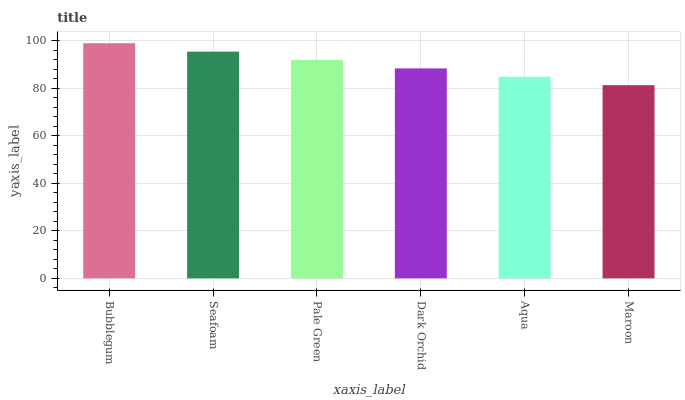Is Maroon the minimum?
Answer yes or no. Yes. Is Bubblegum the maximum?
Answer yes or no. Yes. Is Seafoam the minimum?
Answer yes or no. No. Is Seafoam the maximum?
Answer yes or no. No. Is Bubblegum greater than Seafoam?
Answer yes or no. Yes. Is Seafoam less than Bubblegum?
Answer yes or no. Yes. Is Seafoam greater than Bubblegum?
Answer yes or no. No. Is Bubblegum less than Seafoam?
Answer yes or no. No. Is Pale Green the high median?
Answer yes or no. Yes. Is Dark Orchid the low median?
Answer yes or no. Yes. Is Seafoam the high median?
Answer yes or no. No. Is Aqua the low median?
Answer yes or no. No. 